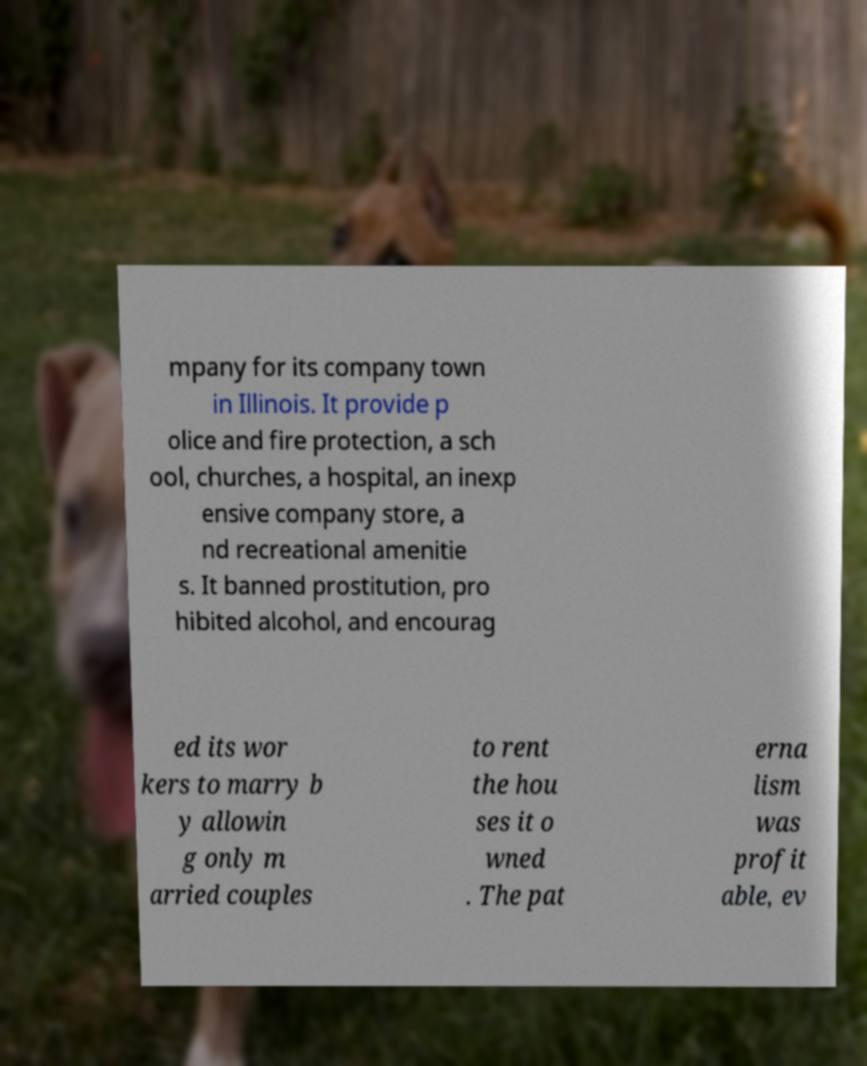Please identify and transcribe the text found in this image. mpany for its company town in Illinois. It provide p olice and fire protection, a sch ool, churches, a hospital, an inexp ensive company store, a nd recreational amenitie s. It banned prostitution, pro hibited alcohol, and encourag ed its wor kers to marry b y allowin g only m arried couples to rent the hou ses it o wned . The pat erna lism was profit able, ev 